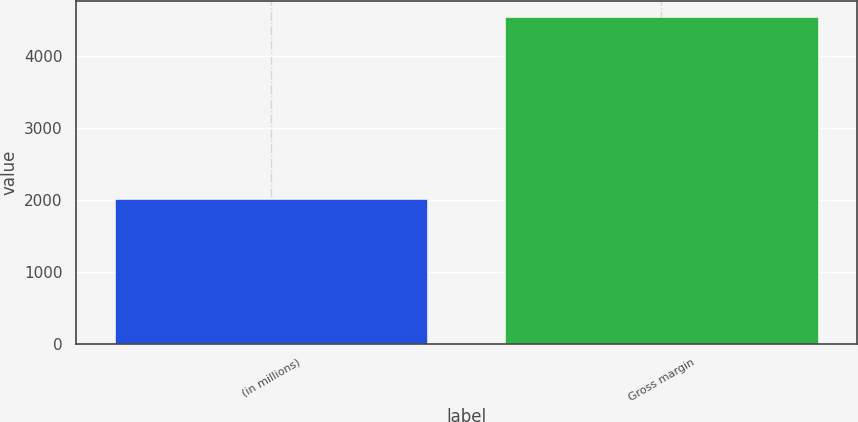<chart> <loc_0><loc_0><loc_500><loc_500><bar_chart><fcel>(in millions)<fcel>Gross margin<nl><fcel>2012<fcel>4541<nl></chart> 